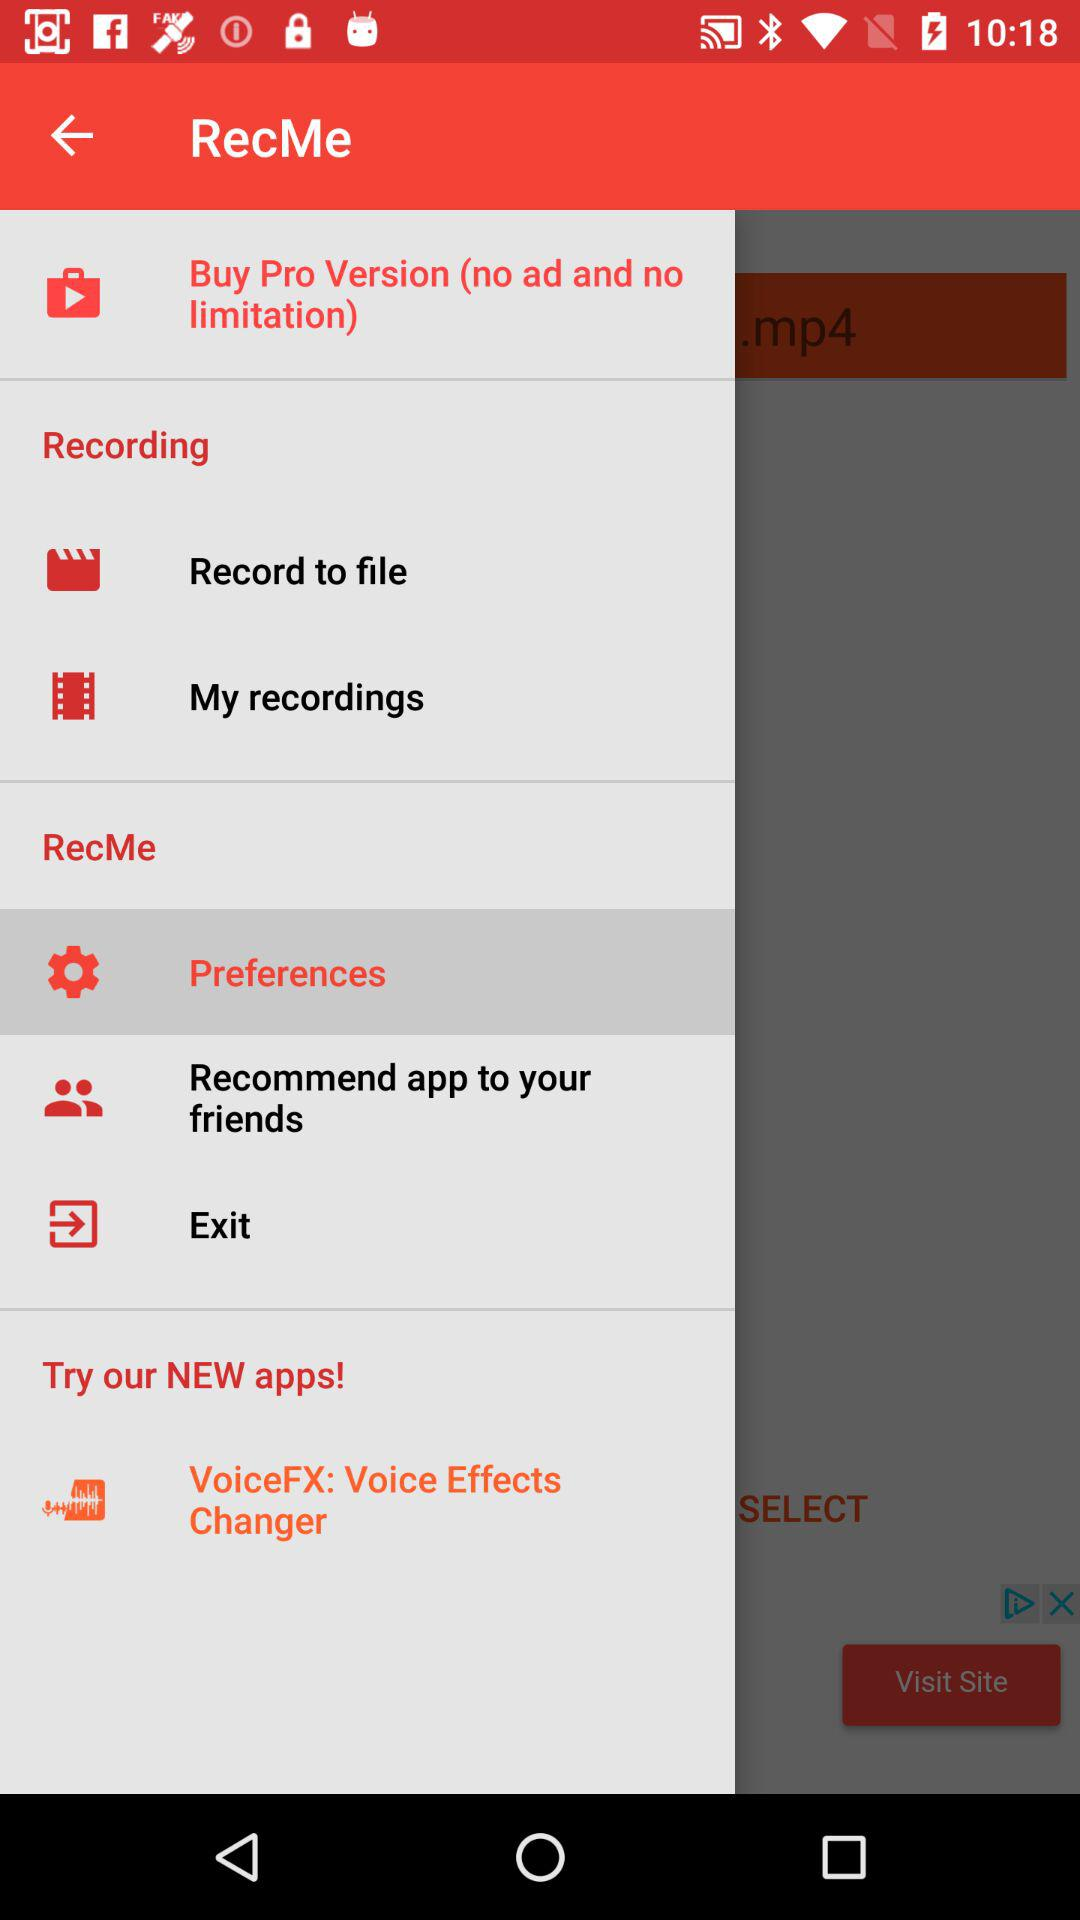What is the app name? The app name is "RecMe". 